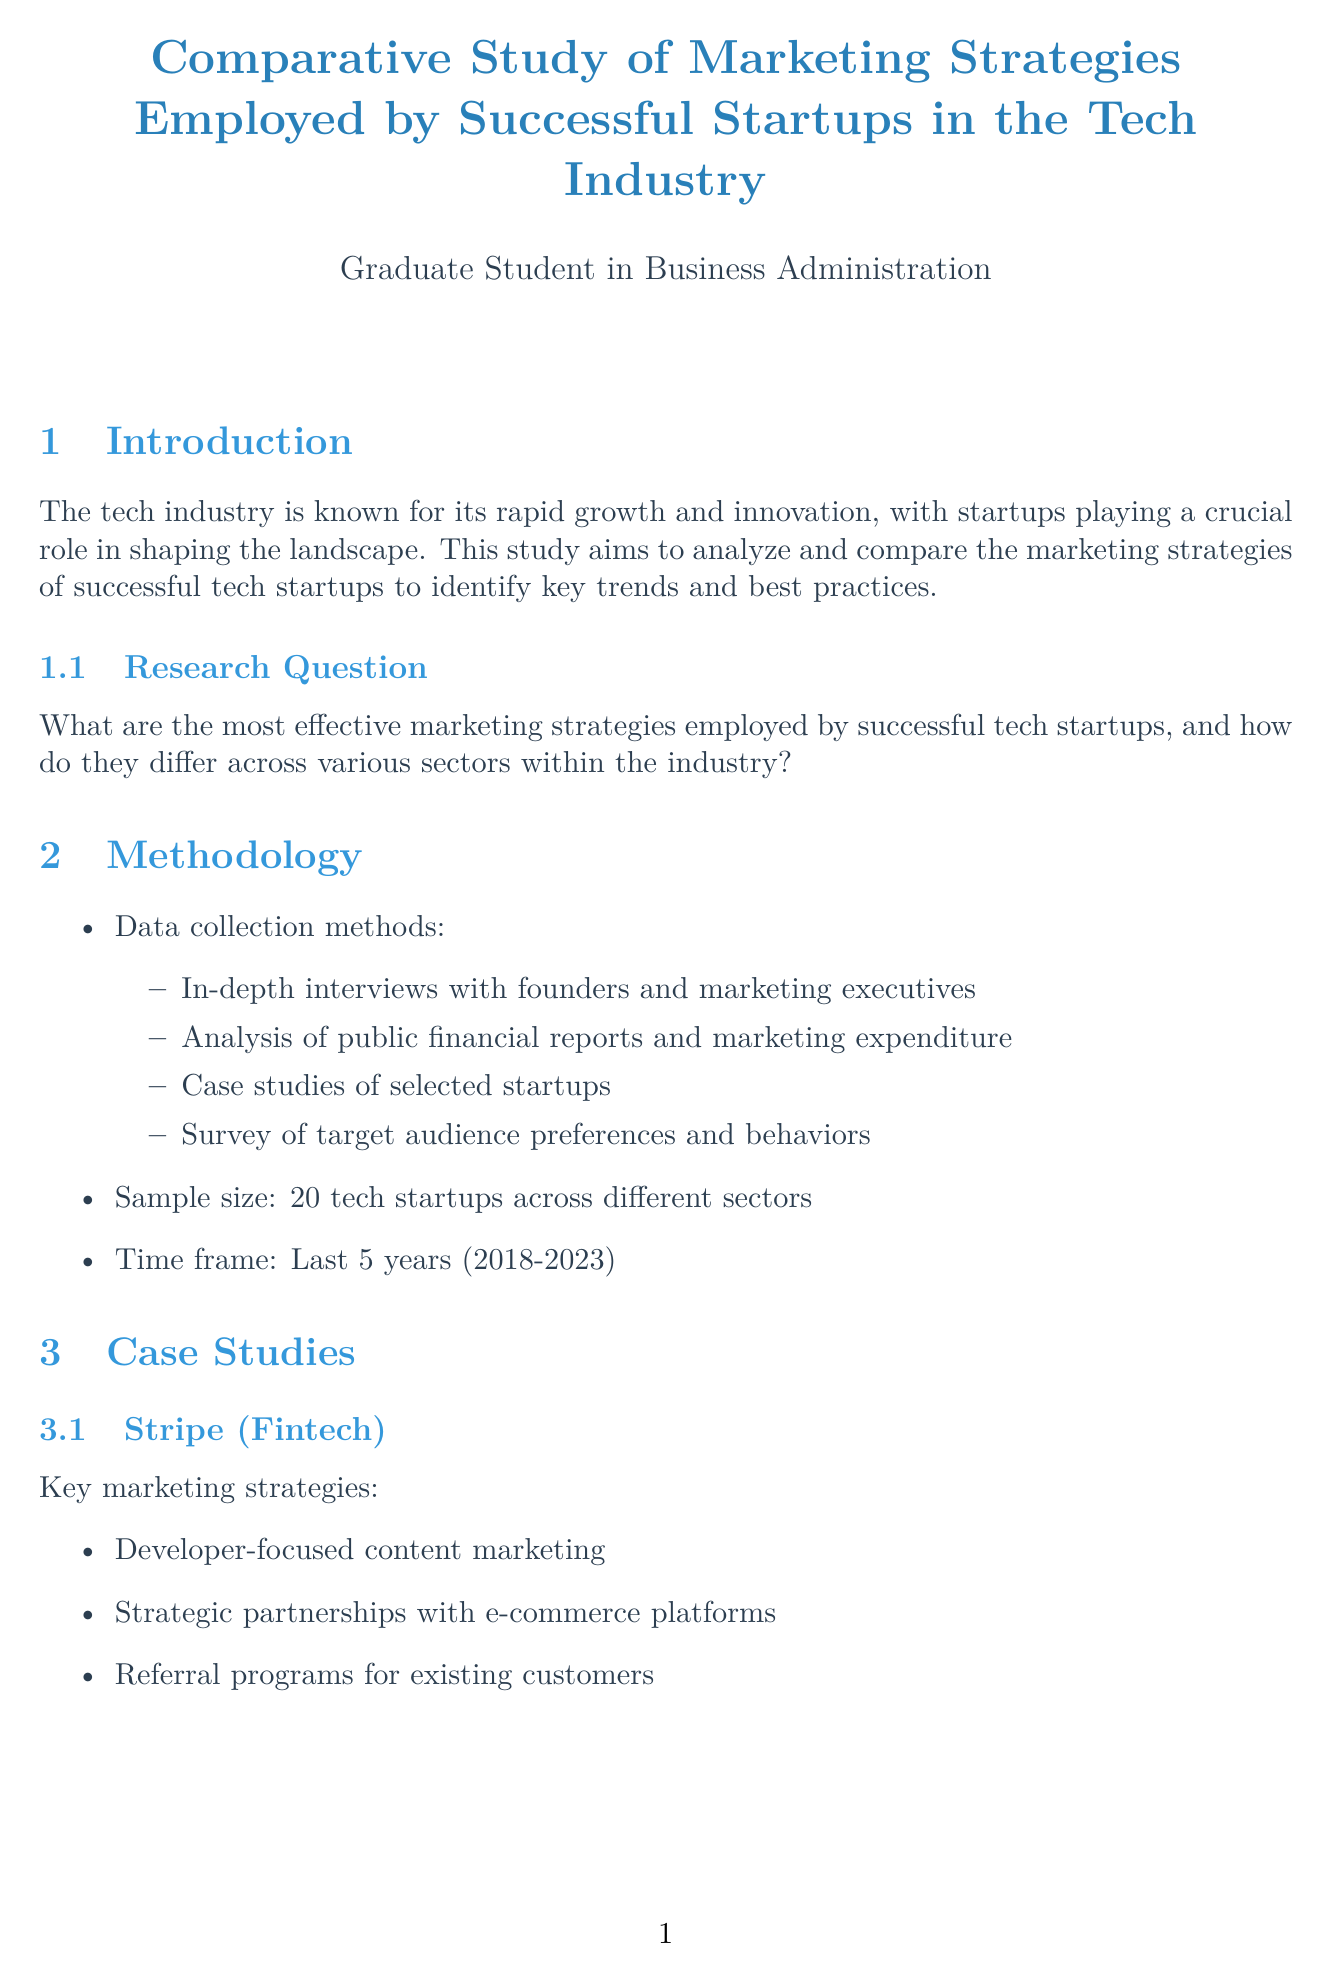What is the report's title? The report's title is indicated at the beginning of the document.
Answer: Comparative Study of Marketing Strategies Employed by Successful Startups in the Tech Industry What sector does Stripe belong to? The sector for each company is specified in the case studies section of the document.
Answer: Fintech What is the average marketing spend percentage? The average marketing spend is mentioned in the budget allocation section of the report.
Answer: 20-30% What are the key marketing strategies employed by Zoom? The key marketing strategies for each case study are listed in the respective sections.
Answer: Freemium model to drive adoption, Integration with other business tools, Focus on user experience and ease of use Which marketing strategy emphasizes community involvement? The document discusses common strategies, and this specific strategy is identified under case studies.
Answer: Community-driven growth and user-generated content What is one future trend mentioned in the report? Future trends are listed in their own section, highlighting anticipated developments in marketing.
Answer: Increased focus on personalization and AI-driven marketing 